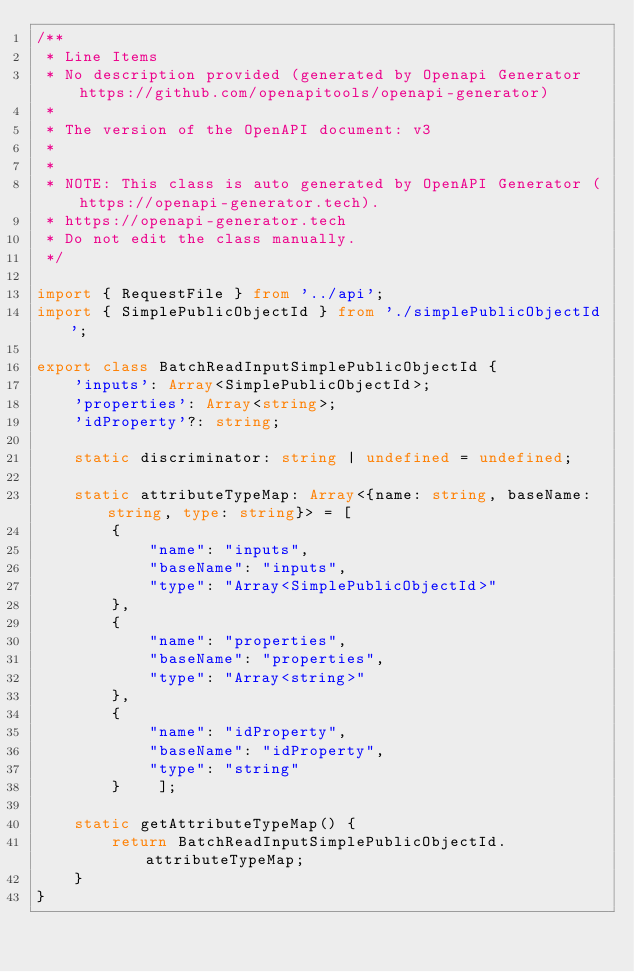Convert code to text. <code><loc_0><loc_0><loc_500><loc_500><_TypeScript_>/**
 * Line Items
 * No description provided (generated by Openapi Generator https://github.com/openapitools/openapi-generator)
 *
 * The version of the OpenAPI document: v3
 * 
 *
 * NOTE: This class is auto generated by OpenAPI Generator (https://openapi-generator.tech).
 * https://openapi-generator.tech
 * Do not edit the class manually.
 */

import { RequestFile } from '../api';
import { SimplePublicObjectId } from './simplePublicObjectId';

export class BatchReadInputSimplePublicObjectId {
    'inputs': Array<SimplePublicObjectId>;
    'properties': Array<string>;
    'idProperty'?: string;

    static discriminator: string | undefined = undefined;

    static attributeTypeMap: Array<{name: string, baseName: string, type: string}> = [
        {
            "name": "inputs",
            "baseName": "inputs",
            "type": "Array<SimplePublicObjectId>"
        },
        {
            "name": "properties",
            "baseName": "properties",
            "type": "Array<string>"
        },
        {
            "name": "idProperty",
            "baseName": "idProperty",
            "type": "string"
        }    ];

    static getAttributeTypeMap() {
        return BatchReadInputSimplePublicObjectId.attributeTypeMap;
    }
}

</code> 